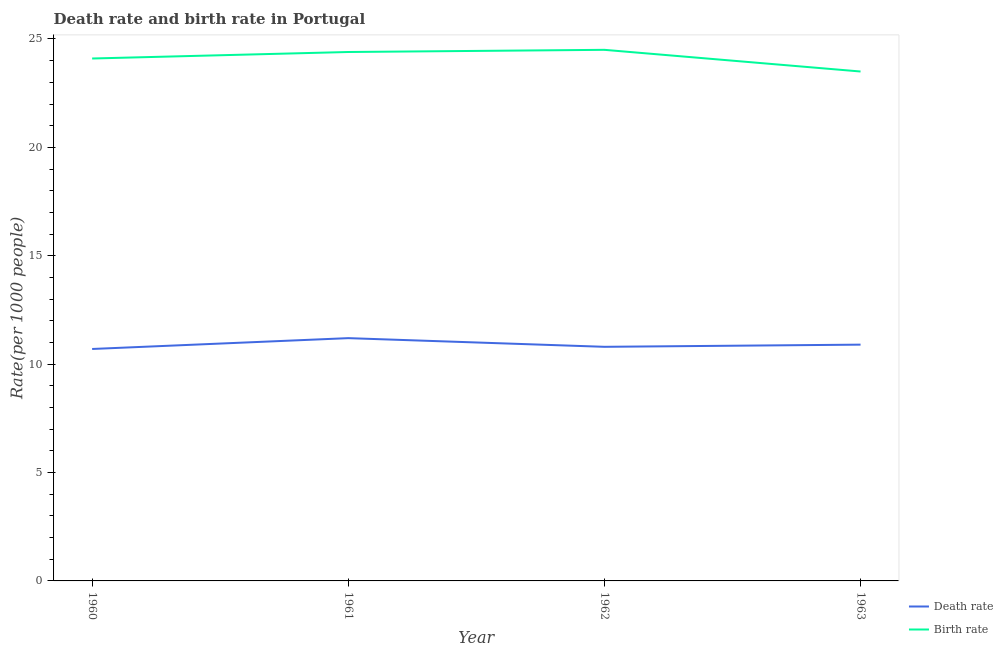How many different coloured lines are there?
Your answer should be very brief. 2. Does the line corresponding to death rate intersect with the line corresponding to birth rate?
Your answer should be compact. No. Is the number of lines equal to the number of legend labels?
Give a very brief answer. Yes. Across all years, what is the maximum birth rate?
Your response must be concise. 24.5. In which year was the birth rate maximum?
Your answer should be compact. 1962. In which year was the birth rate minimum?
Provide a succinct answer. 1963. What is the total birth rate in the graph?
Keep it short and to the point. 96.5. What is the difference between the birth rate in 1961 and that in 1962?
Your answer should be very brief. -0.1. In the year 1960, what is the difference between the death rate and birth rate?
Provide a short and direct response. -13.4. What is the ratio of the death rate in 1961 to that in 1963?
Make the answer very short. 1.03. Is the birth rate in 1961 less than that in 1962?
Give a very brief answer. Yes. What is the difference between the highest and the second highest birth rate?
Offer a terse response. 0.1. What is the difference between the highest and the lowest birth rate?
Provide a succinct answer. 1. Is the sum of the death rate in 1960 and 1961 greater than the maximum birth rate across all years?
Give a very brief answer. No. Does the birth rate monotonically increase over the years?
Provide a succinct answer. No. Is the death rate strictly greater than the birth rate over the years?
Keep it short and to the point. No. Is the birth rate strictly less than the death rate over the years?
Your response must be concise. No. How many lines are there?
Give a very brief answer. 2. Does the graph contain grids?
Offer a very short reply. No. How many legend labels are there?
Provide a succinct answer. 2. How are the legend labels stacked?
Offer a very short reply. Vertical. What is the title of the graph?
Provide a succinct answer. Death rate and birth rate in Portugal. What is the label or title of the X-axis?
Ensure brevity in your answer.  Year. What is the label or title of the Y-axis?
Your answer should be very brief. Rate(per 1000 people). What is the Rate(per 1000 people) of Birth rate in 1960?
Give a very brief answer. 24.1. What is the Rate(per 1000 people) of Birth rate in 1961?
Offer a very short reply. 24.4. What is the Rate(per 1000 people) of Death rate in 1962?
Keep it short and to the point. 10.8. What is the Rate(per 1000 people) of Birth rate in 1962?
Give a very brief answer. 24.5. What is the Rate(per 1000 people) of Death rate in 1963?
Give a very brief answer. 10.9. Across all years, what is the maximum Rate(per 1000 people) in Death rate?
Your response must be concise. 11.2. Across all years, what is the minimum Rate(per 1000 people) of Death rate?
Your answer should be compact. 10.7. What is the total Rate(per 1000 people) in Death rate in the graph?
Ensure brevity in your answer.  43.6. What is the total Rate(per 1000 people) of Birth rate in the graph?
Make the answer very short. 96.5. What is the difference between the Rate(per 1000 people) in Death rate in 1960 and that in 1961?
Offer a terse response. -0.5. What is the difference between the Rate(per 1000 people) in Death rate in 1960 and that in 1962?
Provide a short and direct response. -0.1. What is the difference between the Rate(per 1000 people) of Death rate in 1960 and that in 1963?
Provide a short and direct response. -0.2. What is the difference between the Rate(per 1000 people) in Birth rate in 1961 and that in 1962?
Provide a short and direct response. -0.1. What is the difference between the Rate(per 1000 people) of Birth rate in 1961 and that in 1963?
Offer a terse response. 0.9. What is the difference between the Rate(per 1000 people) of Death rate in 1960 and the Rate(per 1000 people) of Birth rate in 1961?
Provide a short and direct response. -13.7. What is the difference between the Rate(per 1000 people) of Death rate in 1961 and the Rate(per 1000 people) of Birth rate in 1962?
Your answer should be compact. -13.3. What is the difference between the Rate(per 1000 people) in Death rate in 1962 and the Rate(per 1000 people) in Birth rate in 1963?
Keep it short and to the point. -12.7. What is the average Rate(per 1000 people) of Birth rate per year?
Give a very brief answer. 24.12. In the year 1961, what is the difference between the Rate(per 1000 people) of Death rate and Rate(per 1000 people) of Birth rate?
Make the answer very short. -13.2. In the year 1962, what is the difference between the Rate(per 1000 people) of Death rate and Rate(per 1000 people) of Birth rate?
Provide a succinct answer. -13.7. What is the ratio of the Rate(per 1000 people) of Death rate in 1960 to that in 1961?
Give a very brief answer. 0.96. What is the ratio of the Rate(per 1000 people) in Birth rate in 1960 to that in 1962?
Offer a terse response. 0.98. What is the ratio of the Rate(per 1000 people) in Death rate in 1960 to that in 1963?
Offer a very short reply. 0.98. What is the ratio of the Rate(per 1000 people) of Birth rate in 1960 to that in 1963?
Provide a succinct answer. 1.03. What is the ratio of the Rate(per 1000 people) of Death rate in 1961 to that in 1963?
Provide a succinct answer. 1.03. What is the ratio of the Rate(per 1000 people) of Birth rate in 1961 to that in 1963?
Your response must be concise. 1.04. What is the ratio of the Rate(per 1000 people) of Birth rate in 1962 to that in 1963?
Your answer should be very brief. 1.04. What is the difference between the highest and the second highest Rate(per 1000 people) of Death rate?
Your answer should be compact. 0.3. What is the difference between the highest and the lowest Rate(per 1000 people) of Death rate?
Make the answer very short. 0.5. 